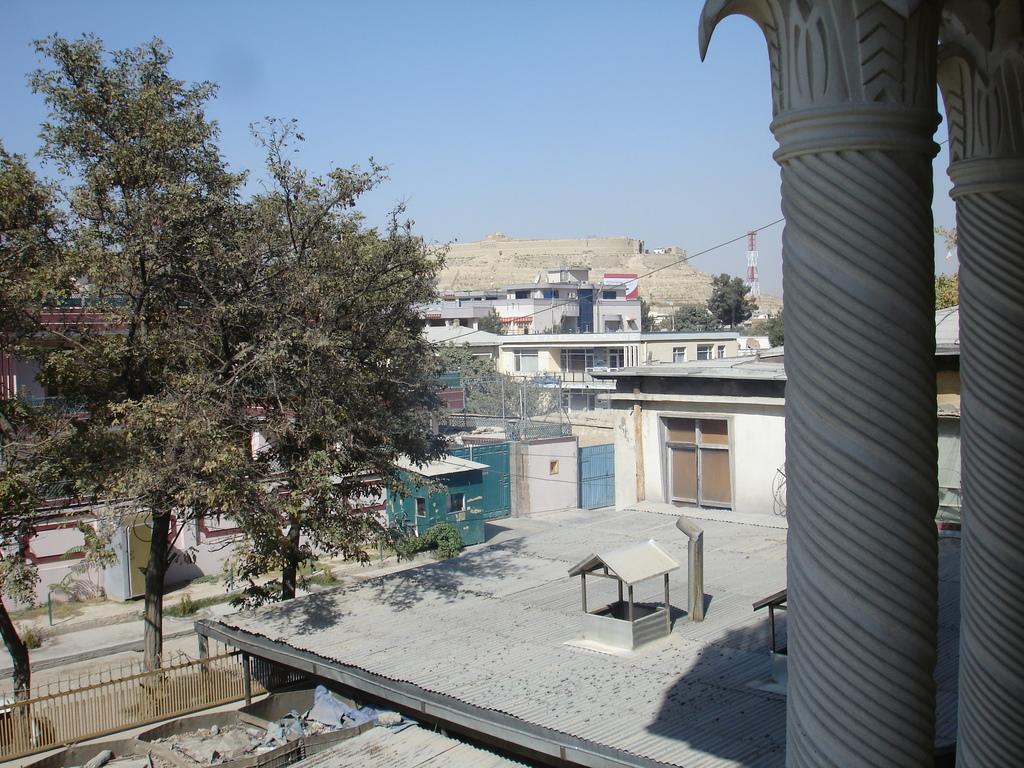How would you summarize this image in a sentence or two? In this image we can see there are so many buildings and trees. 